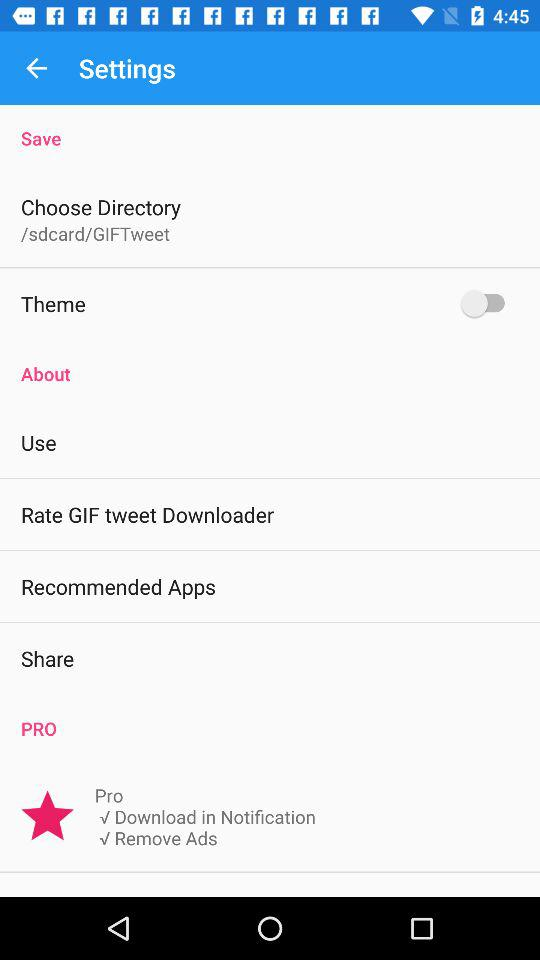What is the status of the "Theme"? The status is off. 